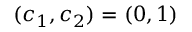Convert formula to latex. <formula><loc_0><loc_0><loc_500><loc_500>( c _ { 1 } , c _ { 2 } ) = ( 0 , 1 )</formula> 